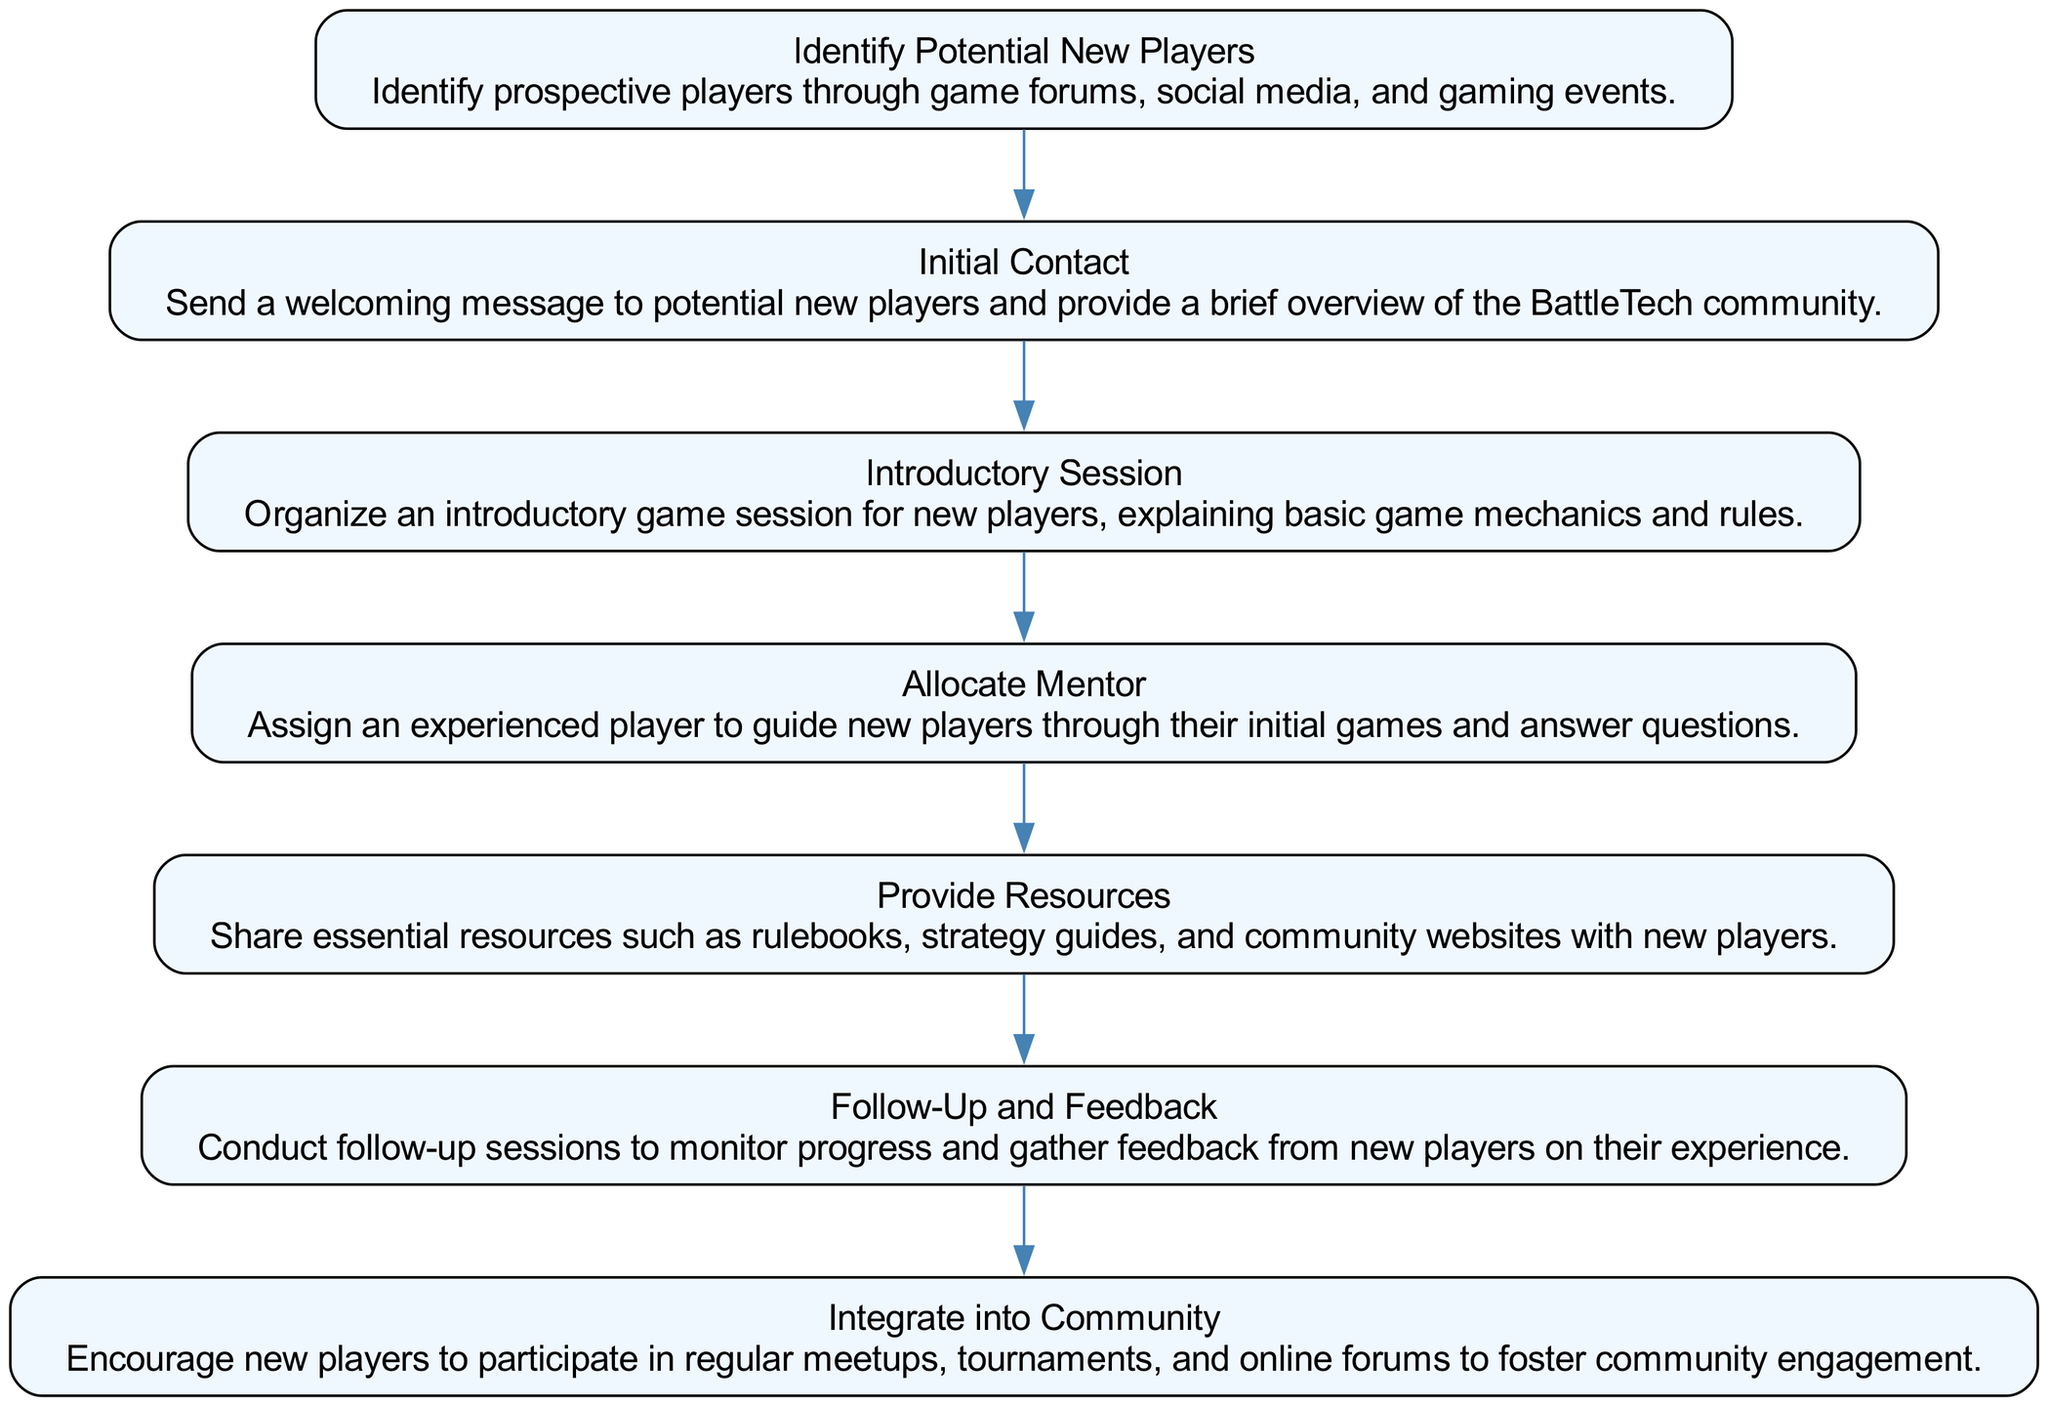What is the first step in the process? The first step, as indicated in the diagram, is "Identify Potential New Players." This is explicitly labeled as the starting node, showing it is the first action to take in the flow.
Answer: Identify Potential New Players How many total steps are there in the process? By counting the nodes in the diagram, we find that there are seven distinct steps listed in the flowchart. Each step corresponds to a specific action within the process of enrolling new players.
Answer: 7 What step follows "Initial Contact"? The diagram shows that the step following "Initial Contact" is "Introductory Session." This is determined by looking at the direct flow from the "Initial Contact" node, leading to the next node.
Answer: Introductory Session What is the role assigned in "Allocate Mentor"? In the "Allocate Mentor" step, the role assigned is that of an experienced player. The connected description indicates that they guide new players and assist with their initial games.
Answer: Experienced player Which step involves sharing resources with new players? The step that involves sharing resources with new players is "Provide Resources." This step specifically mentions the distribution of essential materials such as rulebooks and strategy guides.
Answer: Provide Resources What is the last step in the process? The final step in the process is "Integrate into Community." This is explicitly marked as the last action to be taken in engaging new players with the community activities.
Answer: Integrate into Community Why is "Follow-Up and Feedback" important in this process? "Follow-Up and Feedback" is crucial because it allows the organizers to monitor the progress of new players and gather insights about their experiences. This step ensures that new players are supported and their needs are addressed, fostering retention.
Answer: Monitor progress and gather feedback How are new players encouraged to engage with the community? New players are encouraged to participate in regular meetups, tournaments, and online forums as outlined in the "Integrate into Community" step. This promotes social interaction and involvement with other members.
Answer: Participate in regular meetups, tournaments, and online forums What does the arrow from "Introductory Session" to "Allocate Mentor" signify? The arrow indicates a direct flow of the process, showing that after the "Introductory Session," the next action is to "Allocate Mentor." This connection implies a sequential relationship where the introductory session prepares the new players for mentorship.
Answer: A direct flow to the next action 